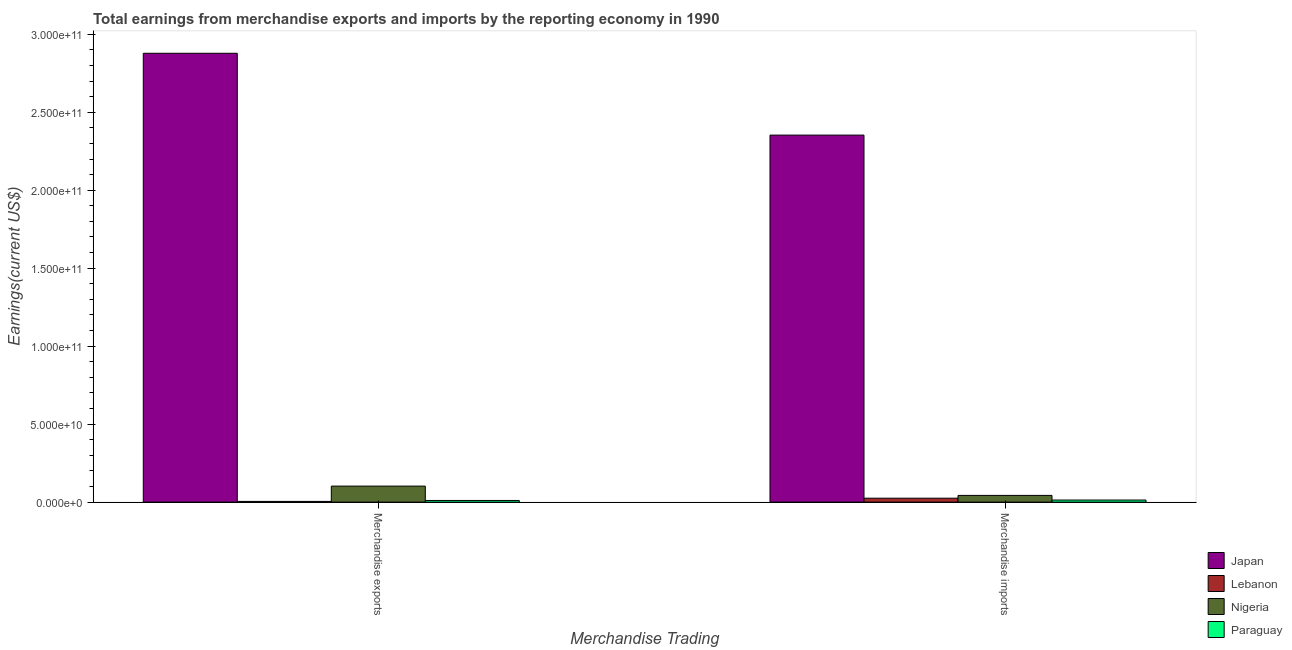How many different coloured bars are there?
Your answer should be very brief. 4. What is the label of the 1st group of bars from the left?
Provide a short and direct response. Merchandise exports. What is the earnings from merchandise imports in Lebanon?
Provide a short and direct response. 2.52e+09. Across all countries, what is the maximum earnings from merchandise imports?
Your answer should be very brief. 2.35e+11. Across all countries, what is the minimum earnings from merchandise imports?
Your response must be concise. 1.34e+09. In which country was the earnings from merchandise imports minimum?
Your response must be concise. Paraguay. What is the total earnings from merchandise exports in the graph?
Make the answer very short. 3.00e+11. What is the difference between the earnings from merchandise exports in Lebanon and that in Paraguay?
Your answer should be compact. -6.06e+08. What is the difference between the earnings from merchandise exports in Lebanon and the earnings from merchandise imports in Japan?
Keep it short and to the point. -2.35e+11. What is the average earnings from merchandise imports per country?
Ensure brevity in your answer.  6.09e+1. What is the difference between the earnings from merchandise imports and earnings from merchandise exports in Lebanon?
Offer a terse response. 2.06e+09. In how many countries, is the earnings from merchandise exports greater than 260000000000 US$?
Ensure brevity in your answer.  1. What is the ratio of the earnings from merchandise imports in Nigeria to that in Japan?
Your answer should be compact. 0.02. What does the 3rd bar from the left in Merchandise imports represents?
Ensure brevity in your answer.  Nigeria. What does the 1st bar from the right in Merchandise exports represents?
Offer a very short reply. Paraguay. What is the difference between two consecutive major ticks on the Y-axis?
Offer a terse response. 5.00e+1. Are the values on the major ticks of Y-axis written in scientific E-notation?
Offer a terse response. Yes. Does the graph contain any zero values?
Your answer should be compact. No. Where does the legend appear in the graph?
Provide a succinct answer. Bottom right. What is the title of the graph?
Ensure brevity in your answer.  Total earnings from merchandise exports and imports by the reporting economy in 1990. Does "New Caledonia" appear as one of the legend labels in the graph?
Ensure brevity in your answer.  No. What is the label or title of the X-axis?
Offer a very short reply. Merchandise Trading. What is the label or title of the Y-axis?
Your answer should be very brief. Earnings(current US$). What is the Earnings(current US$) in Japan in Merchandise exports?
Offer a terse response. 2.88e+11. What is the Earnings(current US$) in Lebanon in Merchandise exports?
Keep it short and to the point. 4.56e+08. What is the Earnings(current US$) in Nigeria in Merchandise exports?
Provide a short and direct response. 1.03e+1. What is the Earnings(current US$) in Paraguay in Merchandise exports?
Provide a succinct answer. 1.06e+09. What is the Earnings(current US$) in Japan in Merchandise imports?
Give a very brief answer. 2.35e+11. What is the Earnings(current US$) of Lebanon in Merchandise imports?
Ensure brevity in your answer.  2.52e+09. What is the Earnings(current US$) of Nigeria in Merchandise imports?
Give a very brief answer. 4.32e+09. What is the Earnings(current US$) of Paraguay in Merchandise imports?
Give a very brief answer. 1.34e+09. Across all Merchandise Trading, what is the maximum Earnings(current US$) in Japan?
Your answer should be compact. 2.88e+11. Across all Merchandise Trading, what is the maximum Earnings(current US$) of Lebanon?
Your response must be concise. 2.52e+09. Across all Merchandise Trading, what is the maximum Earnings(current US$) of Nigeria?
Ensure brevity in your answer.  1.03e+1. Across all Merchandise Trading, what is the maximum Earnings(current US$) of Paraguay?
Your answer should be compact. 1.34e+09. Across all Merchandise Trading, what is the minimum Earnings(current US$) in Japan?
Offer a very short reply. 2.35e+11. Across all Merchandise Trading, what is the minimum Earnings(current US$) in Lebanon?
Give a very brief answer. 4.56e+08. Across all Merchandise Trading, what is the minimum Earnings(current US$) in Nigeria?
Your answer should be very brief. 4.32e+09. Across all Merchandise Trading, what is the minimum Earnings(current US$) in Paraguay?
Give a very brief answer. 1.06e+09. What is the total Earnings(current US$) in Japan in the graph?
Offer a very short reply. 5.23e+11. What is the total Earnings(current US$) in Lebanon in the graph?
Make the answer very short. 2.97e+09. What is the total Earnings(current US$) of Nigeria in the graph?
Your answer should be very brief. 1.46e+1. What is the total Earnings(current US$) of Paraguay in the graph?
Your response must be concise. 2.40e+09. What is the difference between the Earnings(current US$) of Japan in Merchandise exports and that in Merchandise imports?
Keep it short and to the point. 5.25e+1. What is the difference between the Earnings(current US$) of Lebanon in Merchandise exports and that in Merchandise imports?
Offer a very short reply. -2.06e+09. What is the difference between the Earnings(current US$) in Nigeria in Merchandise exports and that in Merchandise imports?
Make the answer very short. 5.96e+09. What is the difference between the Earnings(current US$) in Paraguay in Merchandise exports and that in Merchandise imports?
Offer a very short reply. -2.78e+08. What is the difference between the Earnings(current US$) of Japan in Merchandise exports and the Earnings(current US$) of Lebanon in Merchandise imports?
Provide a succinct answer. 2.85e+11. What is the difference between the Earnings(current US$) of Japan in Merchandise exports and the Earnings(current US$) of Nigeria in Merchandise imports?
Give a very brief answer. 2.83e+11. What is the difference between the Earnings(current US$) of Japan in Merchandise exports and the Earnings(current US$) of Paraguay in Merchandise imports?
Provide a succinct answer. 2.86e+11. What is the difference between the Earnings(current US$) in Lebanon in Merchandise exports and the Earnings(current US$) in Nigeria in Merchandise imports?
Provide a succinct answer. -3.86e+09. What is the difference between the Earnings(current US$) of Lebanon in Merchandise exports and the Earnings(current US$) of Paraguay in Merchandise imports?
Provide a succinct answer. -8.85e+08. What is the difference between the Earnings(current US$) of Nigeria in Merchandise exports and the Earnings(current US$) of Paraguay in Merchandise imports?
Ensure brevity in your answer.  8.93e+09. What is the average Earnings(current US$) in Japan per Merchandise Trading?
Give a very brief answer. 2.62e+11. What is the average Earnings(current US$) of Lebanon per Merchandise Trading?
Your response must be concise. 1.49e+09. What is the average Earnings(current US$) in Nigeria per Merchandise Trading?
Your answer should be compact. 7.30e+09. What is the average Earnings(current US$) of Paraguay per Merchandise Trading?
Offer a terse response. 1.20e+09. What is the difference between the Earnings(current US$) in Japan and Earnings(current US$) in Lebanon in Merchandise exports?
Provide a succinct answer. 2.87e+11. What is the difference between the Earnings(current US$) of Japan and Earnings(current US$) of Nigeria in Merchandise exports?
Provide a succinct answer. 2.78e+11. What is the difference between the Earnings(current US$) of Japan and Earnings(current US$) of Paraguay in Merchandise exports?
Offer a terse response. 2.87e+11. What is the difference between the Earnings(current US$) in Lebanon and Earnings(current US$) in Nigeria in Merchandise exports?
Your response must be concise. -9.82e+09. What is the difference between the Earnings(current US$) of Lebanon and Earnings(current US$) of Paraguay in Merchandise exports?
Offer a terse response. -6.06e+08. What is the difference between the Earnings(current US$) in Nigeria and Earnings(current US$) in Paraguay in Merchandise exports?
Keep it short and to the point. 9.21e+09. What is the difference between the Earnings(current US$) in Japan and Earnings(current US$) in Lebanon in Merchandise imports?
Offer a very short reply. 2.33e+11. What is the difference between the Earnings(current US$) in Japan and Earnings(current US$) in Nigeria in Merchandise imports?
Provide a short and direct response. 2.31e+11. What is the difference between the Earnings(current US$) in Japan and Earnings(current US$) in Paraguay in Merchandise imports?
Keep it short and to the point. 2.34e+11. What is the difference between the Earnings(current US$) in Lebanon and Earnings(current US$) in Nigeria in Merchandise imports?
Your response must be concise. -1.80e+09. What is the difference between the Earnings(current US$) in Lebanon and Earnings(current US$) in Paraguay in Merchandise imports?
Provide a short and direct response. 1.17e+09. What is the difference between the Earnings(current US$) in Nigeria and Earnings(current US$) in Paraguay in Merchandise imports?
Offer a terse response. 2.98e+09. What is the ratio of the Earnings(current US$) of Japan in Merchandise exports to that in Merchandise imports?
Your answer should be compact. 1.22. What is the ratio of the Earnings(current US$) in Lebanon in Merchandise exports to that in Merchandise imports?
Keep it short and to the point. 0.18. What is the ratio of the Earnings(current US$) of Nigeria in Merchandise exports to that in Merchandise imports?
Ensure brevity in your answer.  2.38. What is the ratio of the Earnings(current US$) in Paraguay in Merchandise exports to that in Merchandise imports?
Keep it short and to the point. 0.79. What is the difference between the highest and the second highest Earnings(current US$) in Japan?
Keep it short and to the point. 5.25e+1. What is the difference between the highest and the second highest Earnings(current US$) in Lebanon?
Provide a short and direct response. 2.06e+09. What is the difference between the highest and the second highest Earnings(current US$) in Nigeria?
Keep it short and to the point. 5.96e+09. What is the difference between the highest and the second highest Earnings(current US$) in Paraguay?
Offer a very short reply. 2.78e+08. What is the difference between the highest and the lowest Earnings(current US$) of Japan?
Provide a short and direct response. 5.25e+1. What is the difference between the highest and the lowest Earnings(current US$) in Lebanon?
Give a very brief answer. 2.06e+09. What is the difference between the highest and the lowest Earnings(current US$) of Nigeria?
Your response must be concise. 5.96e+09. What is the difference between the highest and the lowest Earnings(current US$) of Paraguay?
Make the answer very short. 2.78e+08. 